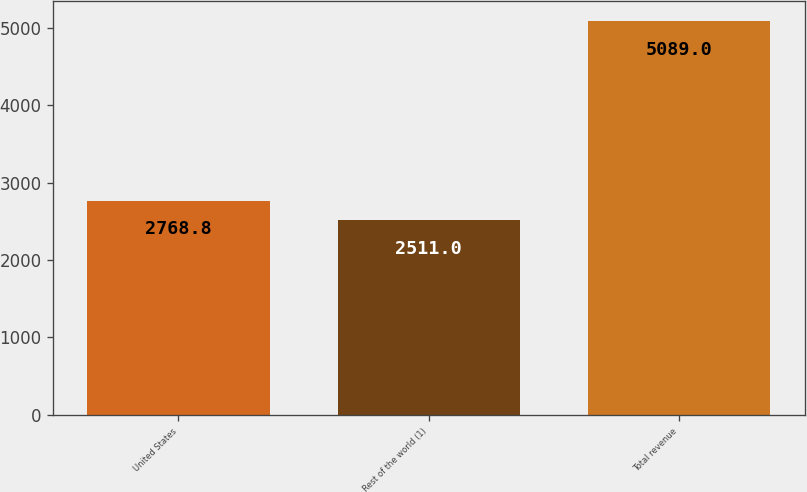Convert chart. <chart><loc_0><loc_0><loc_500><loc_500><bar_chart><fcel>United States<fcel>Rest of the world (1)<fcel>Total revenue<nl><fcel>2768.8<fcel>2511<fcel>5089<nl></chart> 